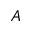Convert formula to latex. <formula><loc_0><loc_0><loc_500><loc_500>A</formula> 